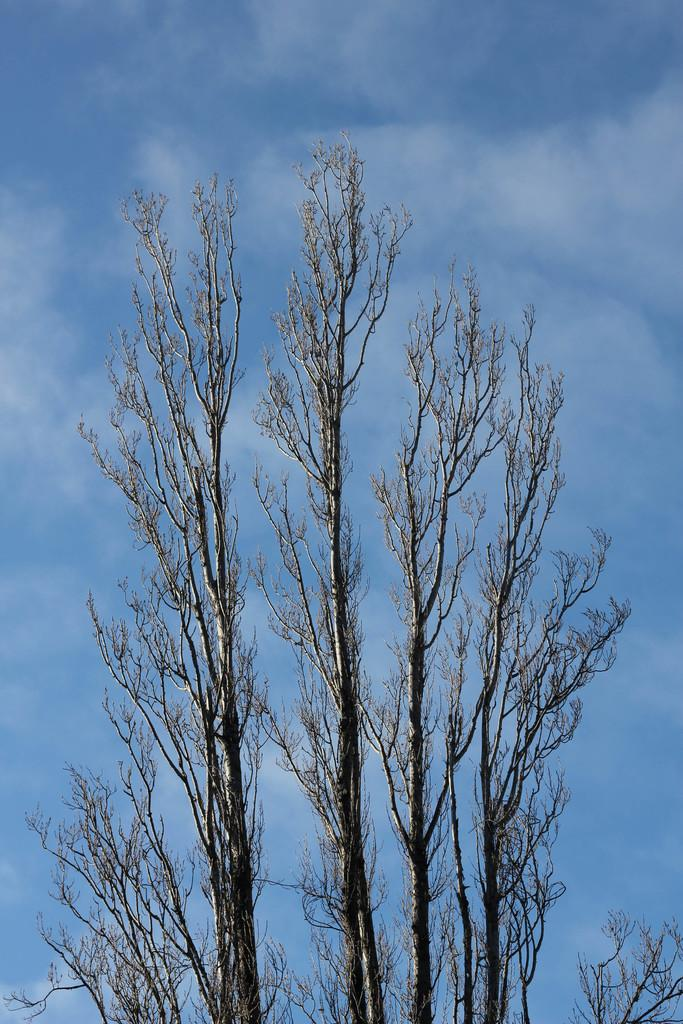What type of vegetation can be seen in the image? There are trees in the image. What can be seen in the sky in the image? There are clouds in the image. What part of the natural environment is visible in the image? The sky is visible in the image. How many pies are being eaten by the frog in the image? There is no frog or pies present in the image. What facial expression does the face in the image have? There is no face present in the image. 